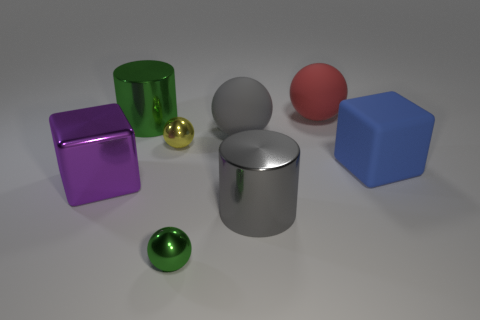Subtract 1 balls. How many balls are left? 3 Add 2 metal blocks. How many objects exist? 10 Subtract all cylinders. How many objects are left? 6 Add 5 large metal cubes. How many large metal cubes exist? 6 Subtract 0 cyan spheres. How many objects are left? 8 Subtract all brown matte cylinders. Subtract all gray things. How many objects are left? 6 Add 3 big gray matte spheres. How many big gray matte spheres are left? 4 